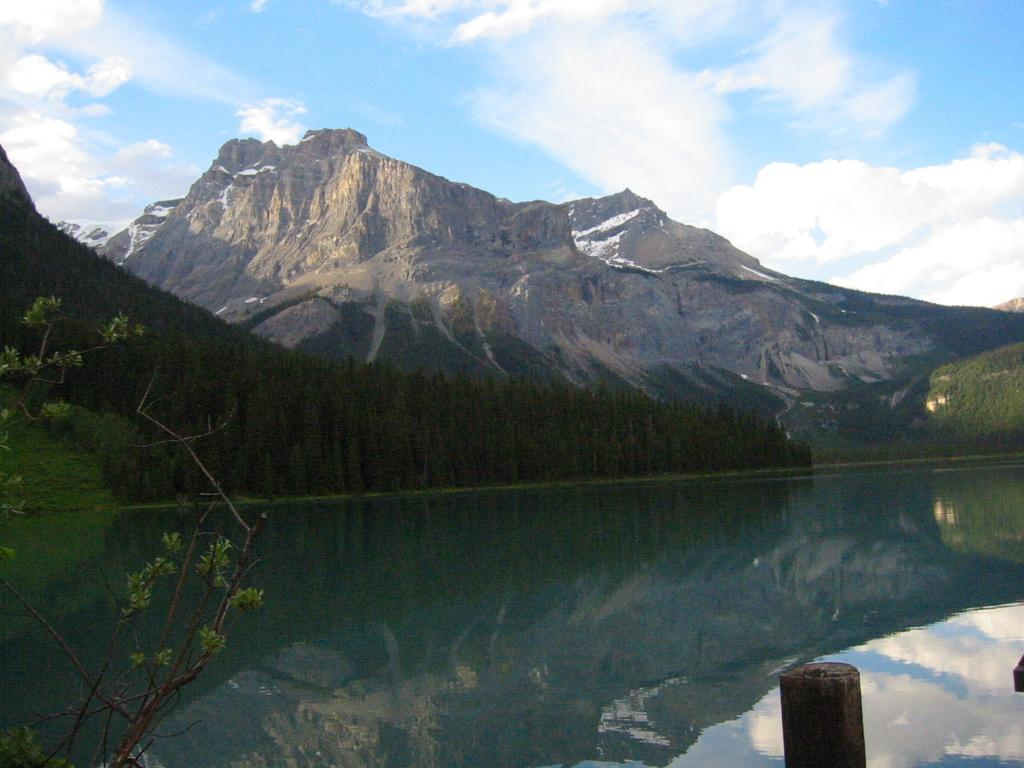What is one of the natural elements present in the image? There is water in the image. What type of vegetation can be seen in the image? There are trees in the image. What geographical feature is visible in the image? There are mountains in the image. What color is the sky in the image? The sky is blue in the image. Can you describe the possible location of the image based on the visible features? The image may have been taken near the mountains. What type of creature can be seen making noise in the image? There is no creature present in the image, and therefore no such activity can be observed. How many pizzas are visible in the image? There are no pizzas present in the image. 